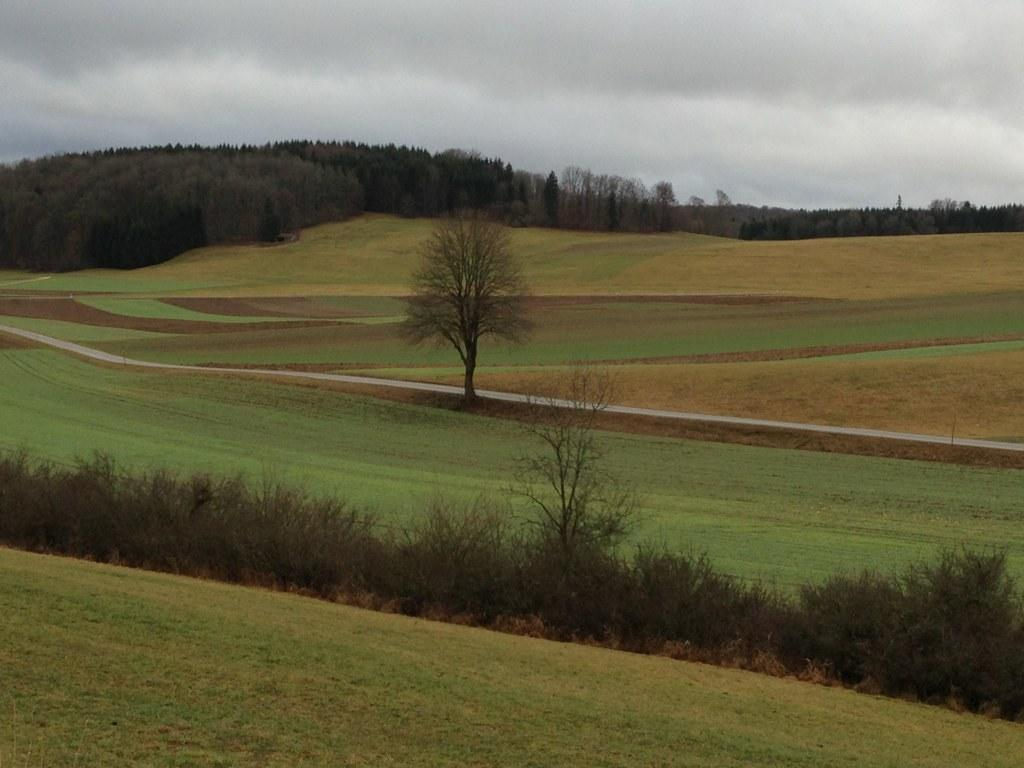What type of vegetation is on the ground in the image? There is grass on the ground in the image. What other natural elements can be seen in the image? There are trees in the image. What man-made feature is present in the image? There is a road in the image. What can be seen in the background of the image? There are trees and the sky visible in the background of the image. What is the condition of the sky in the image? Clouds are present in the sky in the image. What type of beef is being served at the picnic in the image? There is no picnic or beef present in the image; it features grass, trees, a road, and a sky with clouds. How does the pollution affect the environment in the image? There is no mention of pollution in the image, as it focuses on natural elements like grass, trees, and the sky. 